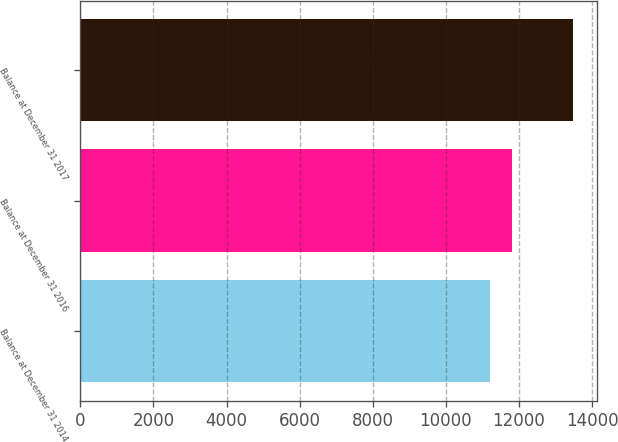Convert chart. <chart><loc_0><loc_0><loc_500><loc_500><bar_chart><fcel>Balance at December 31 2014<fcel>Balance at December 31 2016<fcel>Balance at December 31 2017<nl><fcel>11208<fcel>11820<fcel>13468<nl></chart> 